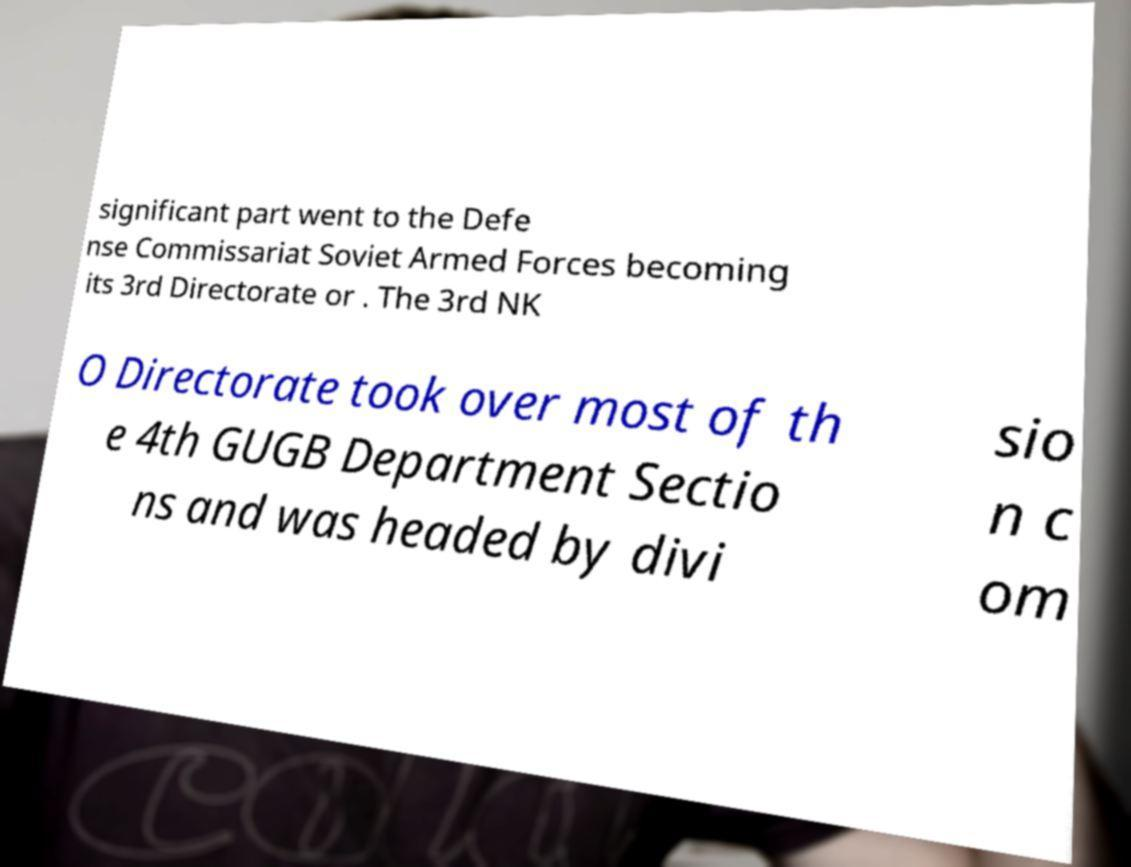What messages or text are displayed in this image? I need them in a readable, typed format. significant part went to the Defe nse Commissariat Soviet Armed Forces becoming its 3rd Directorate or . The 3rd NK O Directorate took over most of th e 4th GUGB Department Sectio ns and was headed by divi sio n c om 